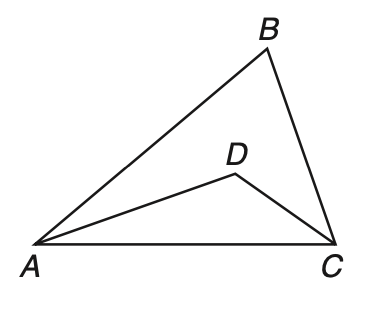Answer the mathemtical geometry problem and directly provide the correct option letter.
Question: In \triangle A B C, A D and D C are angle bisectors and m \angle B = 76. What is the measure of \angle A D C?
Choices: A: 26 B: 52 C: 76 D: 128 D 